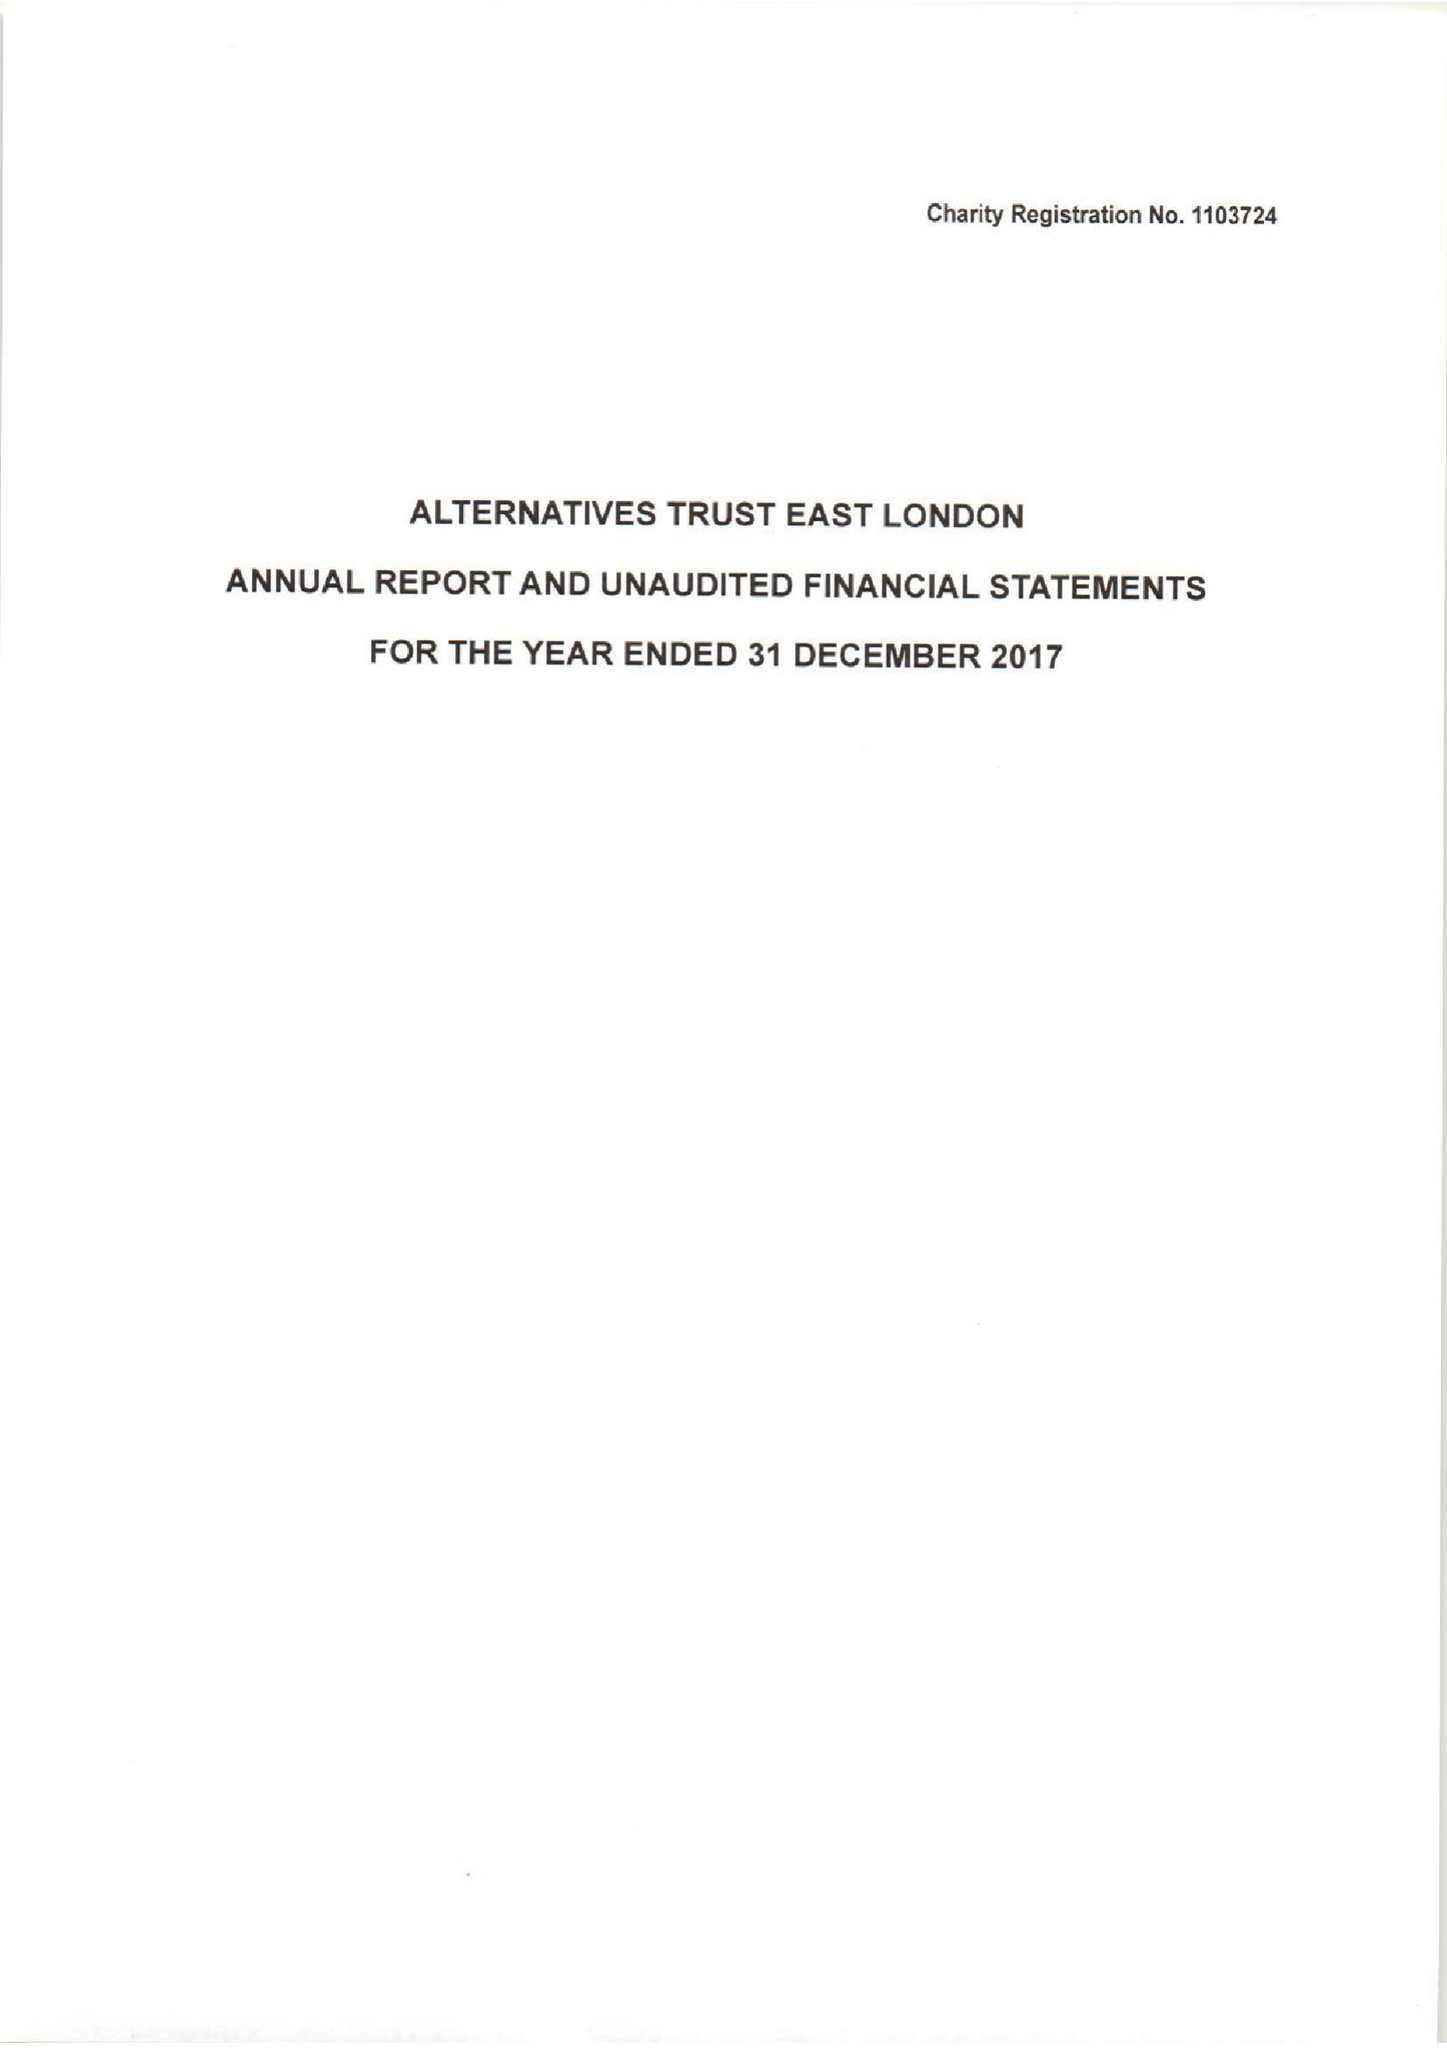What is the value for the charity_name?
Answer the question using a single word or phrase. Alternatives Trust East London 